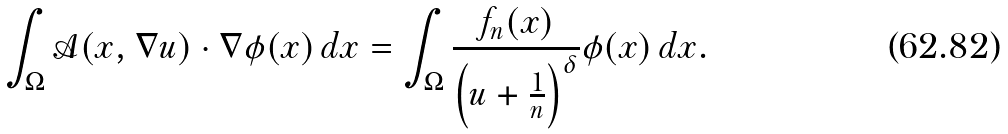<formula> <loc_0><loc_0><loc_500><loc_500>\int _ { \Omega } \mathcal { A } ( x , \nabla u ) \cdot \nabla \phi ( x ) \, d x & = \int _ { \Omega } \frac { f _ { n } ( x ) } { \left ( u + \frac { 1 } { n } \right ) ^ { \delta } } \phi ( x ) \, d x .</formula> 